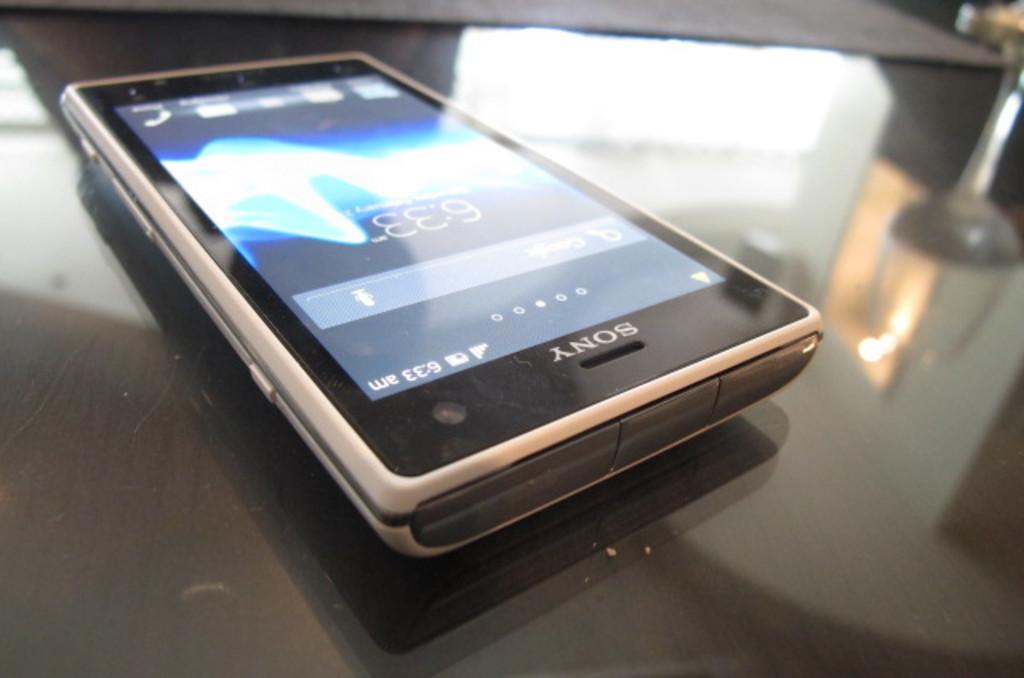<image>
Offer a succinct explanation of the picture presented. A Sony phone on a desk displaying the time 6.33 